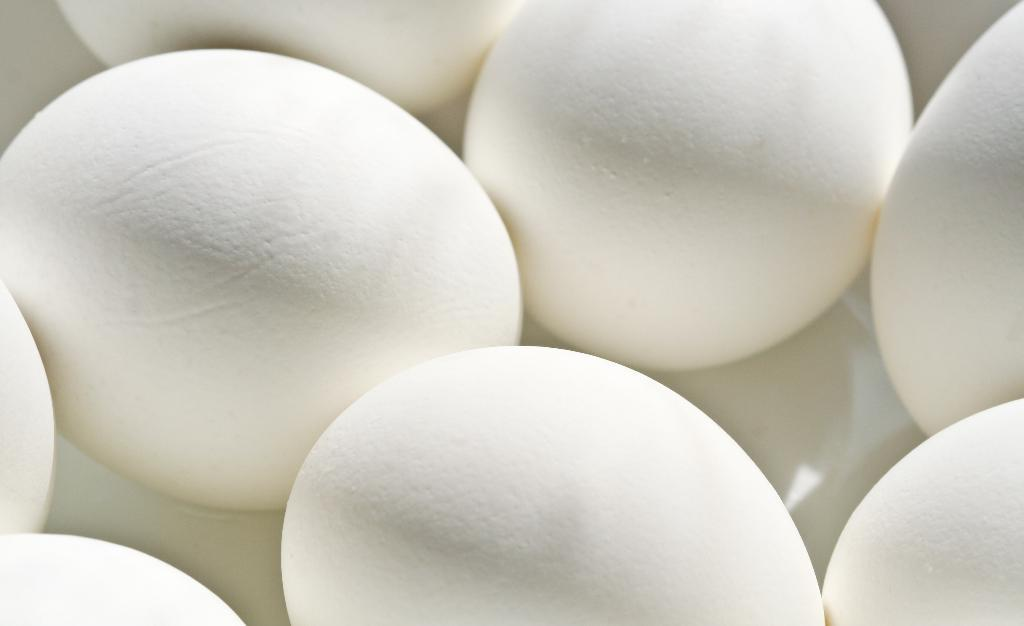What is the main subject of the image? The main subject of the image is a group of eggs. What hobbies do the eggs enjoy in the image? There is no information about the eggs' hobbies in the image, as eggs do not have hobbies. 